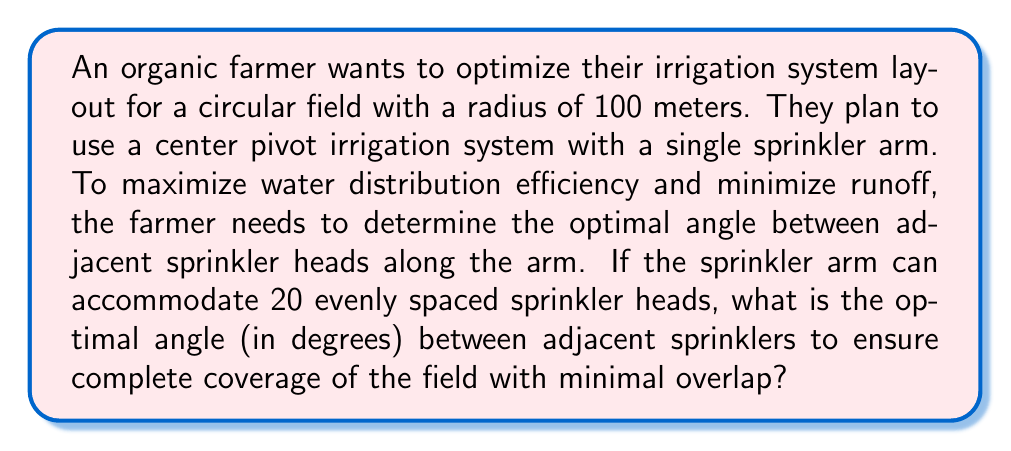What is the answer to this math problem? Let's approach this step-by-step:

1) The sprinkler arm covers the radius of the circular field, which is 100 meters.

2) There are 20 sprinkler heads evenly spaced along the arm.

3) To find the angle between adjacent sprinklers, we need to consider the full circle (360°) divided by the number of sprinklers:

   $$\theta = \frac{360°}{20} = 18°$$

4) However, this angle would result in gaps between the watered areas. We need to ensure overlap for complete coverage.

5) The optimal angle should be slightly less than 18° to create this overlap. A common rule of thumb in irrigation design is to reduce the angle by about 20% to ensure proper coverage.

6) Calculate the optimal angle:

   $$\theta_{optimal} = 18° \times (1 - 0.20) = 18° \times 0.80 = 14.4°$$

7) This angle will ensure that each sprinkler covers slightly more than its designated sector, creating the necessary overlap for complete field coverage while minimizing excessive water use and potential runoff.

[asy]
import geometry;

size(200);
draw(circle((0,0),100), blue);
for(int i=0; i<20; ++i) {
  draw((0,0)--(100*cos(i*14.4*pi/180), 100*sin(i*14.4*pi/180)), red);
}
draw(arc((0,0), 50, 0, 14.4), green+1);
label("14.4°", (40,10), green);
[/asy]
Answer: 14.4° 